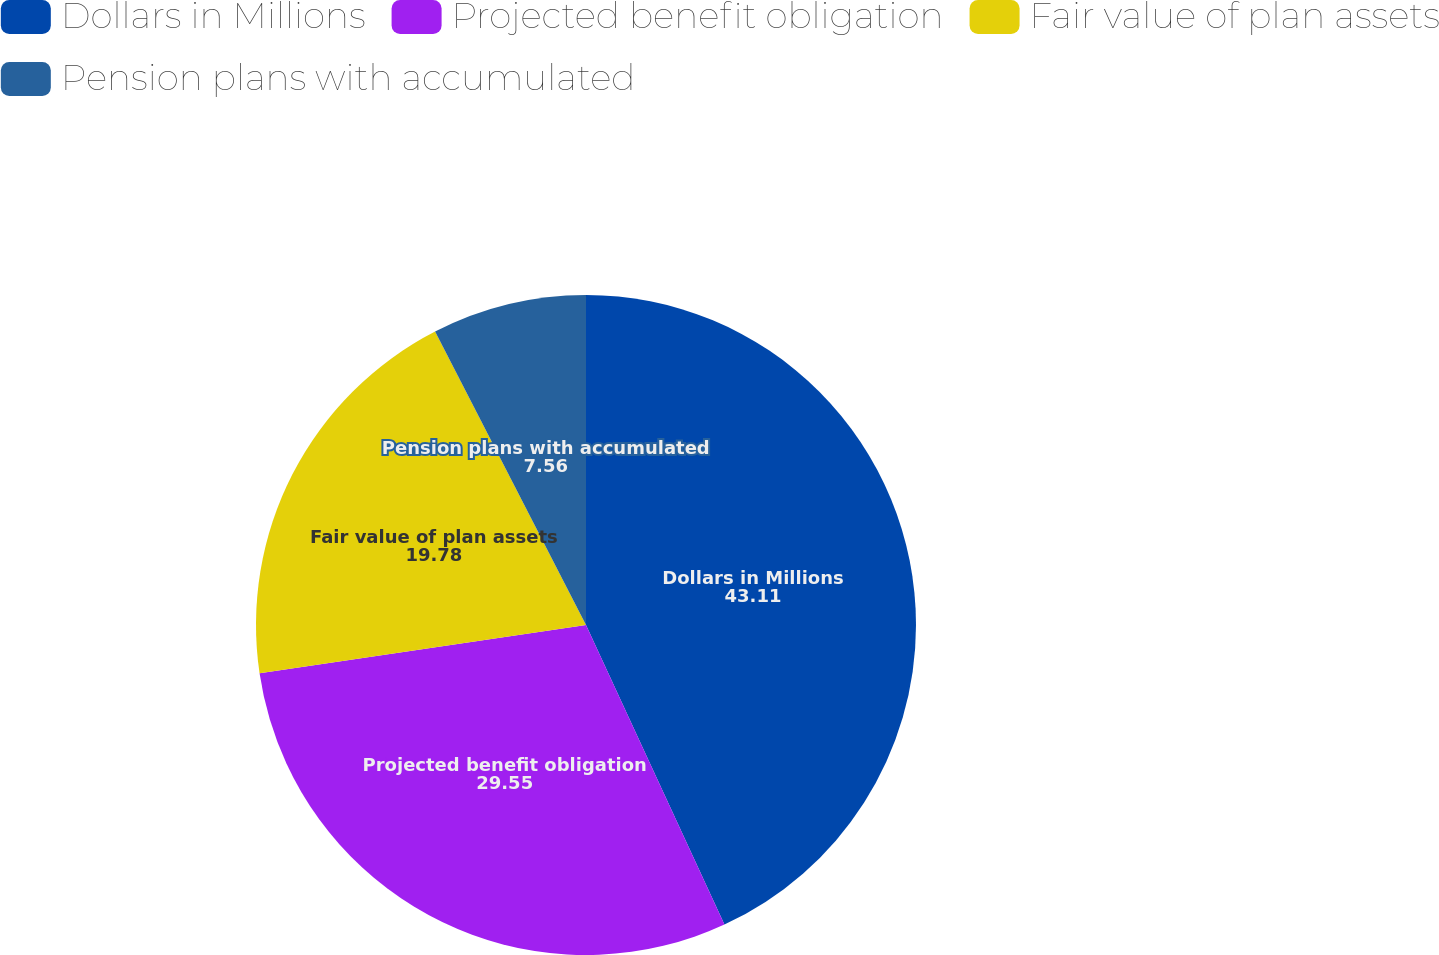Convert chart to OTSL. <chart><loc_0><loc_0><loc_500><loc_500><pie_chart><fcel>Dollars in Millions<fcel>Projected benefit obligation<fcel>Fair value of plan assets<fcel>Pension plans with accumulated<nl><fcel>43.11%<fcel>29.55%<fcel>19.78%<fcel>7.56%<nl></chart> 